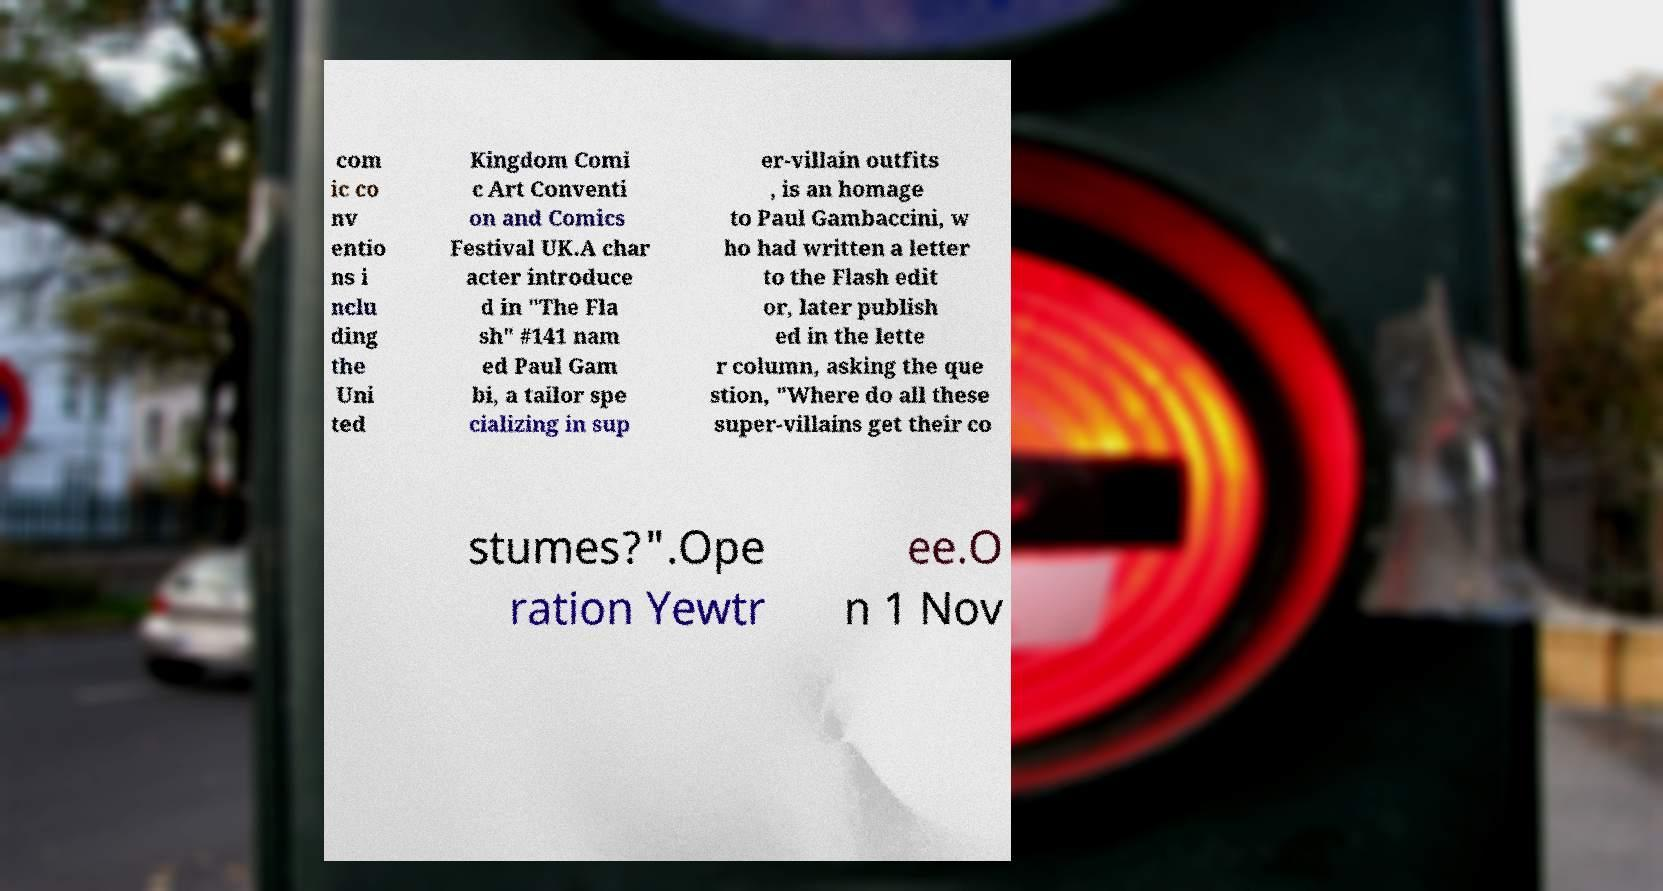Could you extract and type out the text from this image? com ic co nv entio ns i nclu ding the Uni ted Kingdom Comi c Art Conventi on and Comics Festival UK.A char acter introduce d in "The Fla sh" #141 nam ed Paul Gam bi, a tailor spe cializing in sup er-villain outfits , is an homage to Paul Gambaccini, w ho had written a letter to the Flash edit or, later publish ed in the lette r column, asking the que stion, "Where do all these super-villains get their co stumes?".Ope ration Yewtr ee.O n 1 Nov 